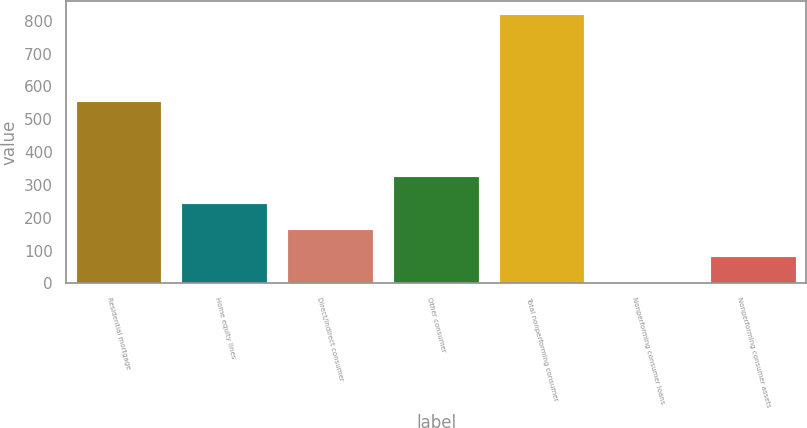<chart> <loc_0><loc_0><loc_500><loc_500><bar_chart><fcel>Residential mortgage<fcel>Home equity lines<fcel>Direct/Indirect consumer<fcel>Other consumer<fcel>Total nonperforming consumer<fcel>Nonperforming consumer loans<fcel>Nonperforming consumer assets<nl><fcel>554<fcel>242.27<fcel>161.59<fcel>322.95<fcel>818.68<fcel>0.23<fcel>80.91<nl></chart> 